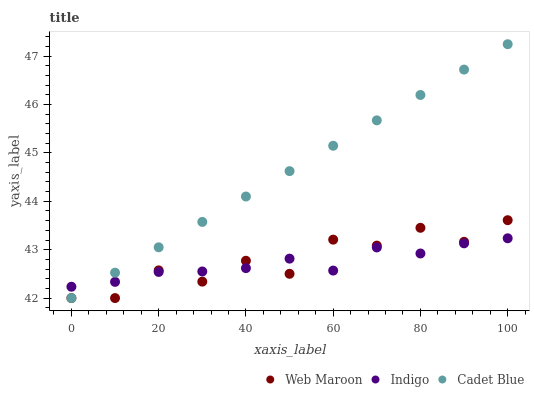Does Indigo have the minimum area under the curve?
Answer yes or no. Yes. Does Cadet Blue have the maximum area under the curve?
Answer yes or no. Yes. Does Web Maroon have the minimum area under the curve?
Answer yes or no. No. Does Web Maroon have the maximum area under the curve?
Answer yes or no. No. Is Cadet Blue the smoothest?
Answer yes or no. Yes. Is Web Maroon the roughest?
Answer yes or no. Yes. Is Web Maroon the smoothest?
Answer yes or no. No. Is Cadet Blue the roughest?
Answer yes or no. No. Does Cadet Blue have the lowest value?
Answer yes or no. Yes. Does Cadet Blue have the highest value?
Answer yes or no. Yes. Does Web Maroon have the highest value?
Answer yes or no. No. Does Web Maroon intersect Indigo?
Answer yes or no. Yes. Is Web Maroon less than Indigo?
Answer yes or no. No. Is Web Maroon greater than Indigo?
Answer yes or no. No. 